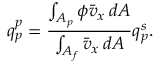<formula> <loc_0><loc_0><loc_500><loc_500>q _ { p } ^ { p } = \frac { \int _ { A _ { p } } \phi \bar { v } _ { x } \, d A } { \int _ { A _ { f } } \bar { v } _ { x } \, d A } q _ { p } ^ { s } .</formula> 